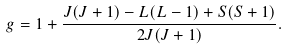<formula> <loc_0><loc_0><loc_500><loc_500>g = 1 + \frac { J ( J + 1 ) - L ( L - 1 ) + S ( S + 1 ) } { 2 J ( J + 1 ) } .</formula> 